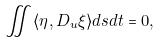Convert formula to latex. <formula><loc_0><loc_0><loc_500><loc_500>\iint \langle \eta , D _ { u } \xi \rangle d s d t = 0 ,</formula> 